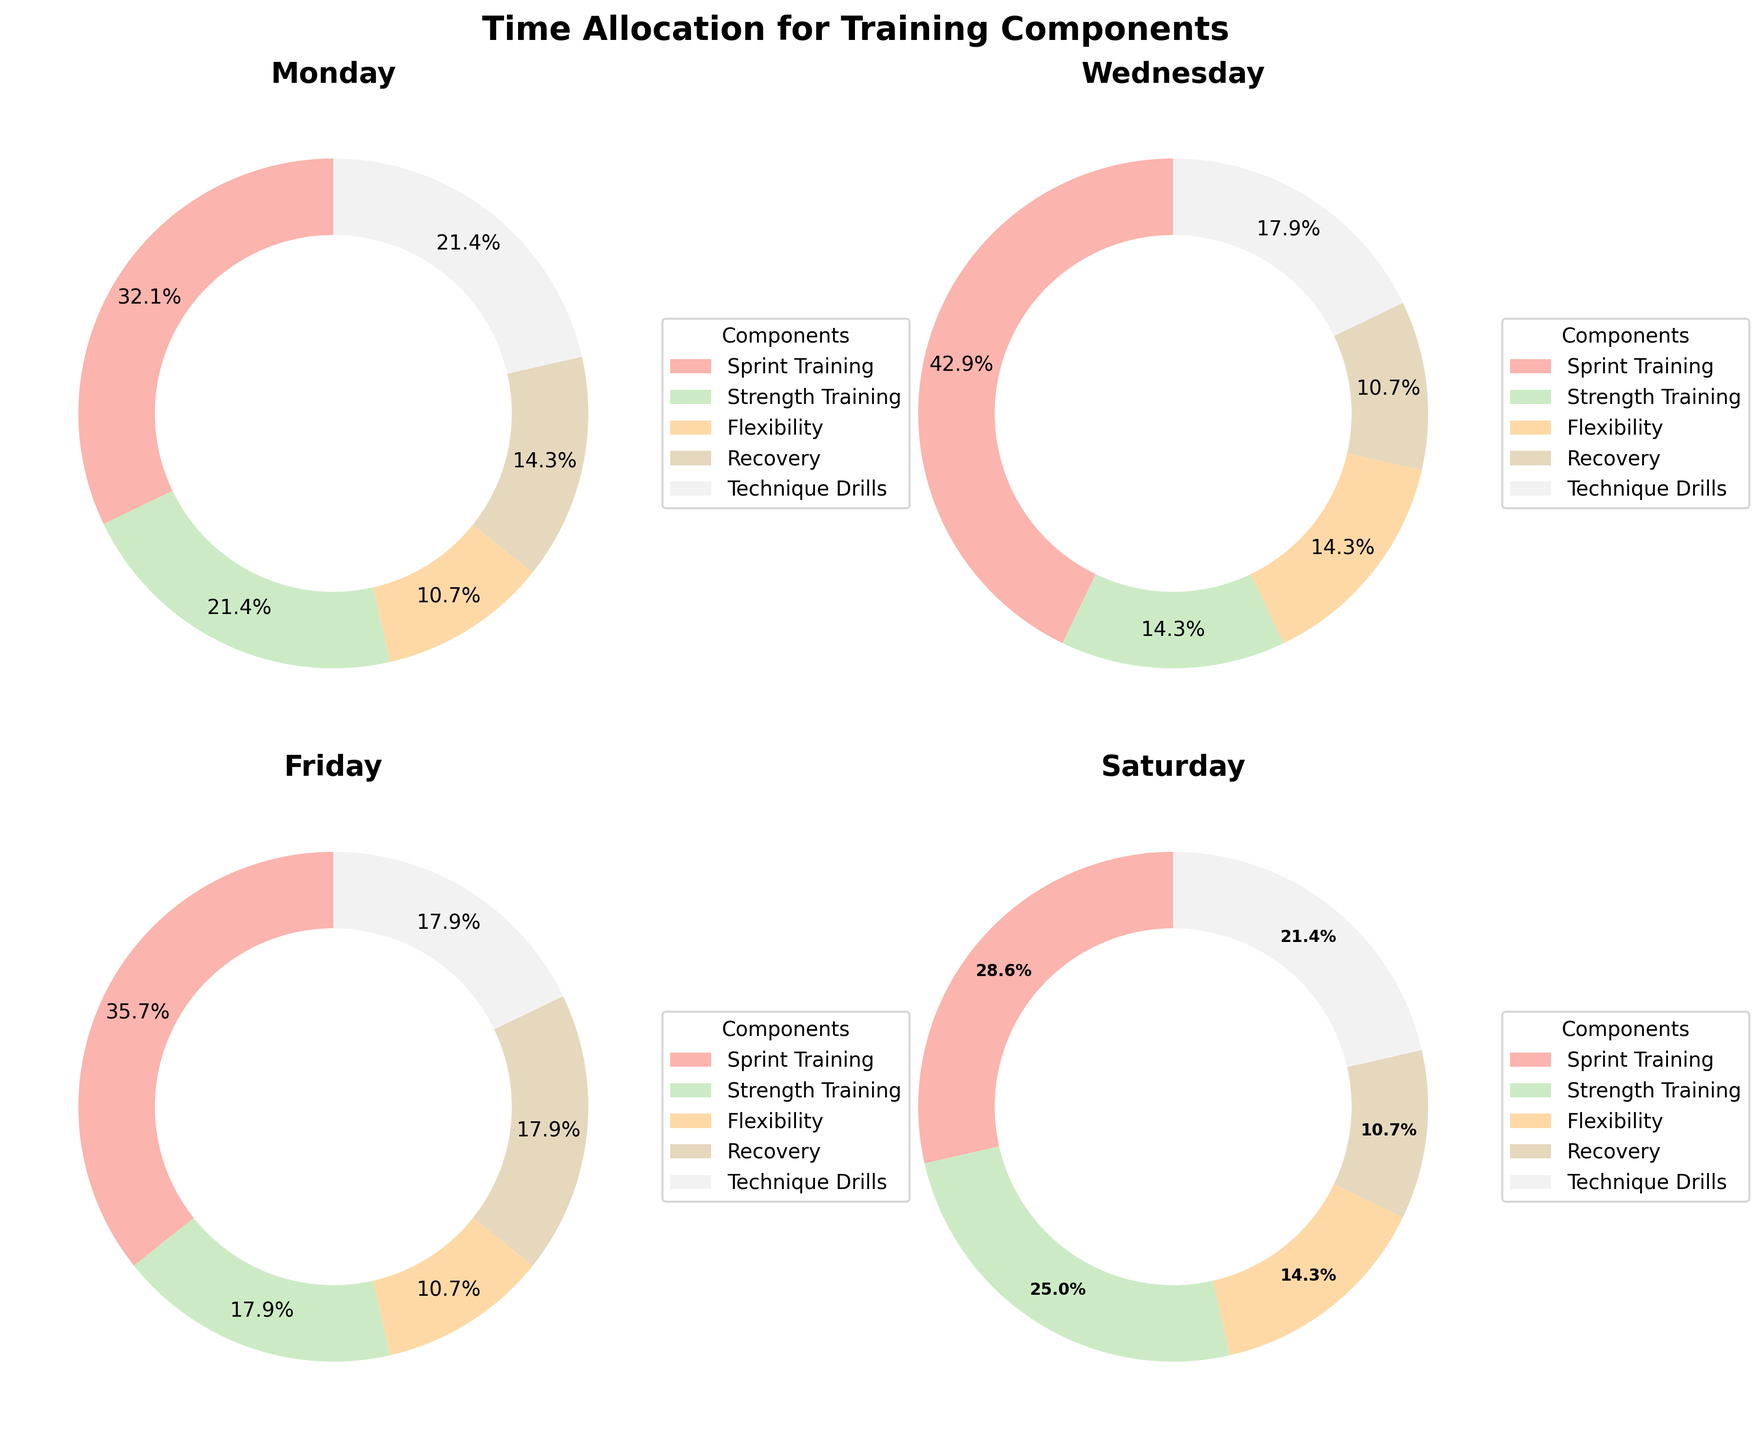How many training components are illustrated in the pie charts? Each pie chart slice represents a training component. There are five components shown: Sprint Training, Strength Training, Flexibility, Recovery, and Technique Drills.
Answer: 5 Which day allocates the most time to Sprint Training? Comparing the Sprint Training slices across all pie charts, Wednesday has the largest share at 60 minutes.
Answer: Wednesday What is the average time allocated to Flexibility across all days? Add up the Flexibility times and divide by the number of days: (15 + 20 + 15 + 20) / 4 = 70 / 4 = 17.5 minutes.
Answer: 17.5 minutes Which day has the most balanced allocation among different training components? Balance can be judged by how similar the slices are in size. Saturday's chart shows more evenly sized slices compared to other days, suggesting a more balanced allocation.
Answer: Saturday How much total time is spent on Technique Drills across all days? Sum the Technique Drills times: 30 + 25 + 25 + 30 = 110 minutes.
Answer: 110 minutes Which day allocates the least time to Recovery? Identify the smallest Recovery slice, which belongs to Wednesday with 15 minutes.
Answer: Wednesday Compare the time spent on Strength Training on Monday and Saturday. How much more or less time is allocated to it on these two days? Monday allocates 30 minutes and Saturday 35 minutes; therefore, Saturday has 5 more minutes.
Answer: 5 more minutes What's the proportion of time spent on Strength Training relative to Sprint Training on Wednesday? Calculate the proportion: Strength Training 20 minutes / Sprint Training 60 minutes = 1/3 or approximately 33.3%.
Answer: 33.3% Is there any day where more time is spent on Flexibility compared to Recovery? If yes, specify the day(s). Compare Flexibility and Recovery slices for each day: None of the days show more time for Flexibility than Recovery.
Answer: No 